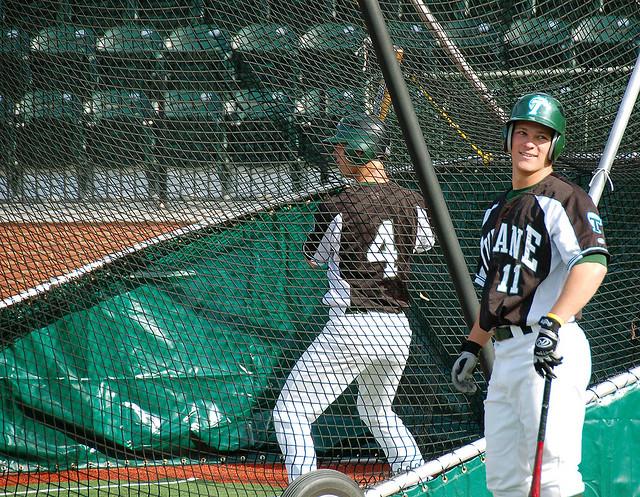What no is visible of the player?
Write a very short answer. 11. What sports are they playing?
Answer briefly. Baseball. What is the number on the players back?
Quick response, please. 4. What sport are they playing?
Quick response, please. Baseball. What is the number on the back of the player's shirt?
Be succinct. 4. What color is his helmet?
Write a very short answer. Green. 